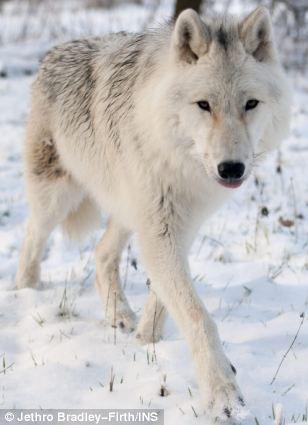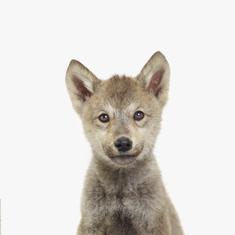The first image is the image on the left, the second image is the image on the right. Assess this claim about the two images: "The left and right image contains the same number of wolves.". Correct or not? Answer yes or no. Yes. 